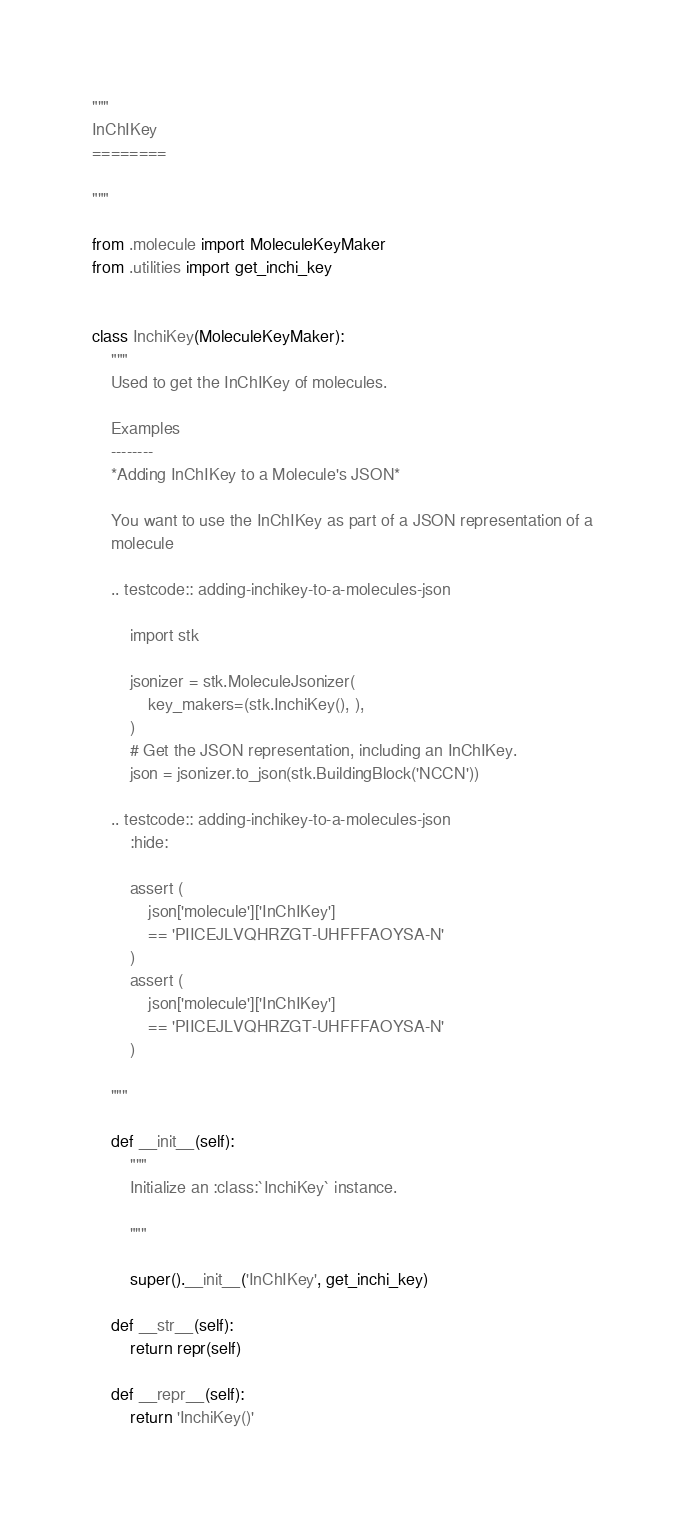Convert code to text. <code><loc_0><loc_0><loc_500><loc_500><_Python_>"""
InChIKey
========

"""

from .molecule import MoleculeKeyMaker
from .utilities import get_inchi_key


class InchiKey(MoleculeKeyMaker):
    """
    Used to get the InChIKey of molecules.

    Examples
    --------
    *Adding InChIKey to a Molecule's JSON*

    You want to use the InChIKey as part of a JSON representation of a
    molecule

    .. testcode:: adding-inchikey-to-a-molecules-json

        import stk

        jsonizer = stk.MoleculeJsonizer(
            key_makers=(stk.InchiKey(), ),
        )
        # Get the JSON representation, including an InChIKey.
        json = jsonizer.to_json(stk.BuildingBlock('NCCN'))

    .. testcode:: adding-inchikey-to-a-molecules-json
        :hide:

        assert (
            json['molecule']['InChIKey']
            == 'PIICEJLVQHRZGT-UHFFFAOYSA-N'
        )
        assert (
            json['molecule']['InChIKey']
            == 'PIICEJLVQHRZGT-UHFFFAOYSA-N'
        )

    """

    def __init__(self):
        """
        Initialize an :class:`InchiKey` instance.

        """

        super().__init__('InChIKey', get_inchi_key)

    def __str__(self):
        return repr(self)

    def __repr__(self):
        return 'InchiKey()'
</code> 